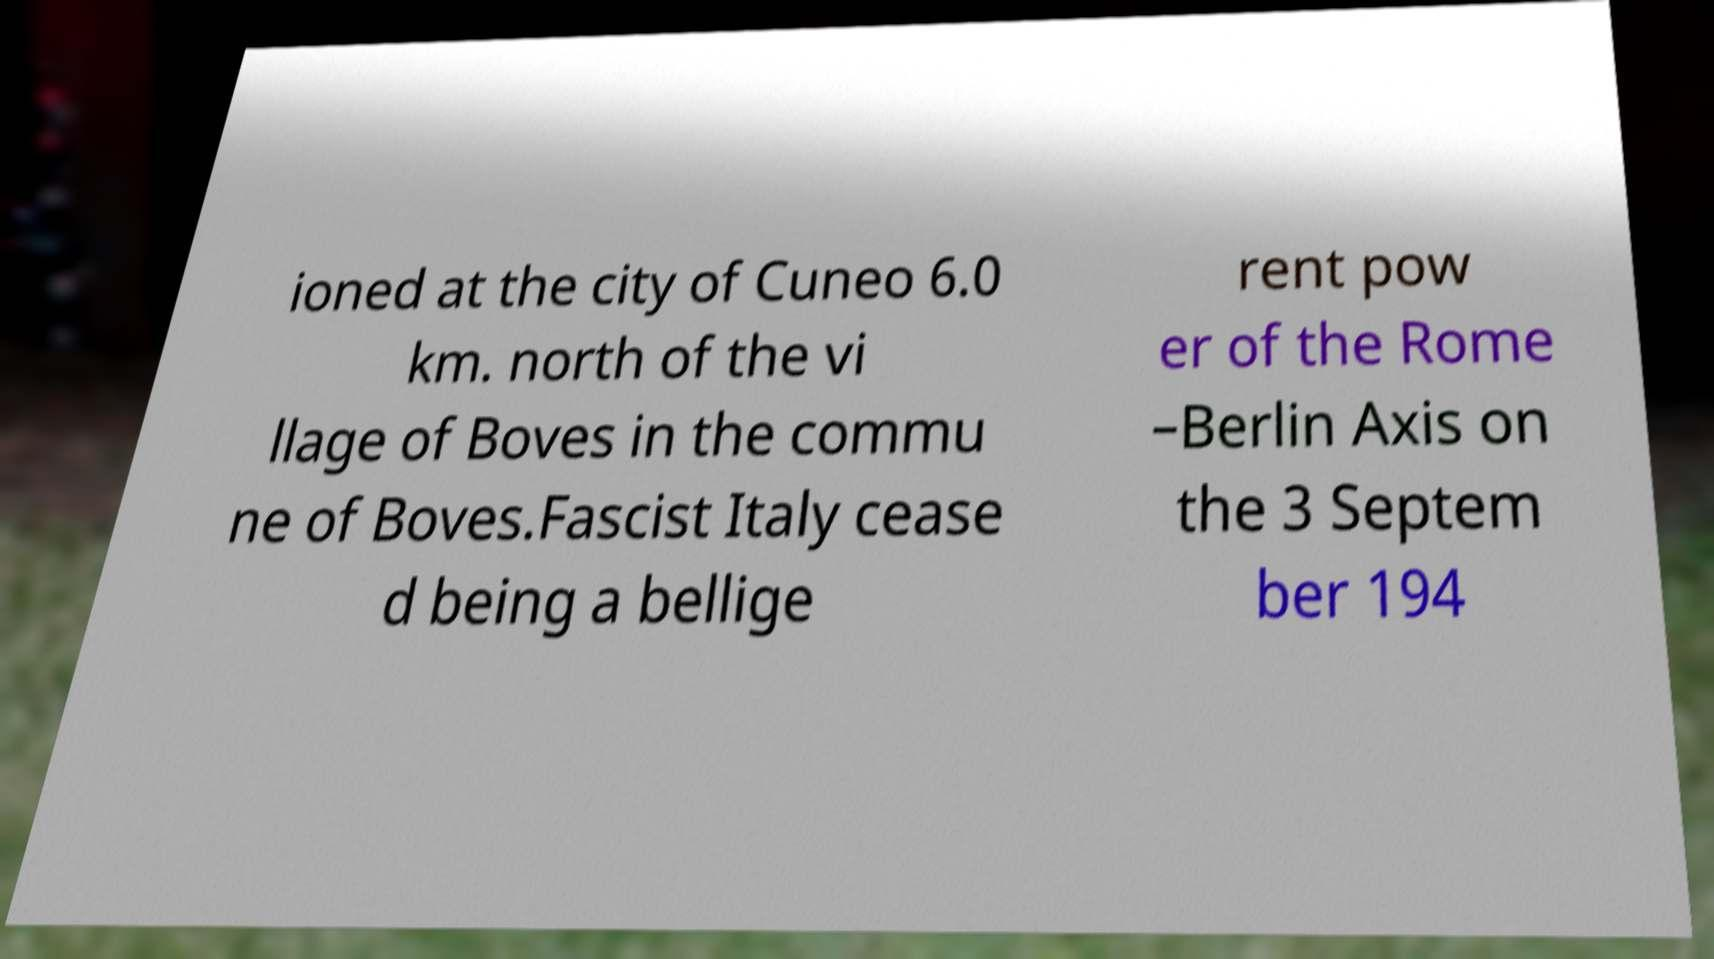I need the written content from this picture converted into text. Can you do that? ioned at the city of Cuneo 6.0 km. north of the vi llage of Boves in the commu ne of Boves.Fascist Italy cease d being a bellige rent pow er of the Rome –Berlin Axis on the 3 Septem ber 194 